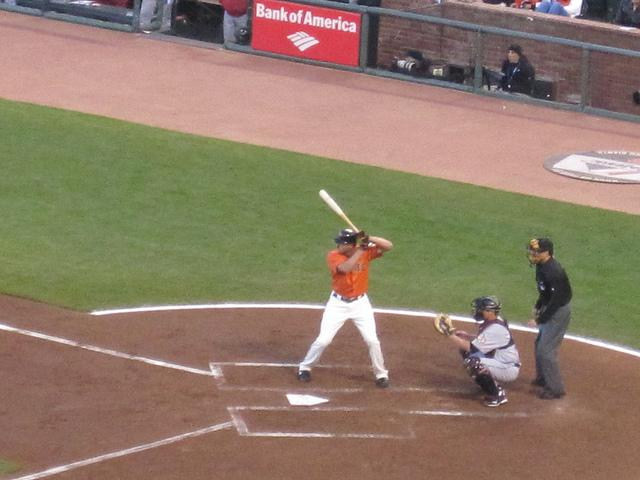What type of service sponsors this stadium?

Choices:
A) banking
B) dining
C) crafting
D) plumbing banking 